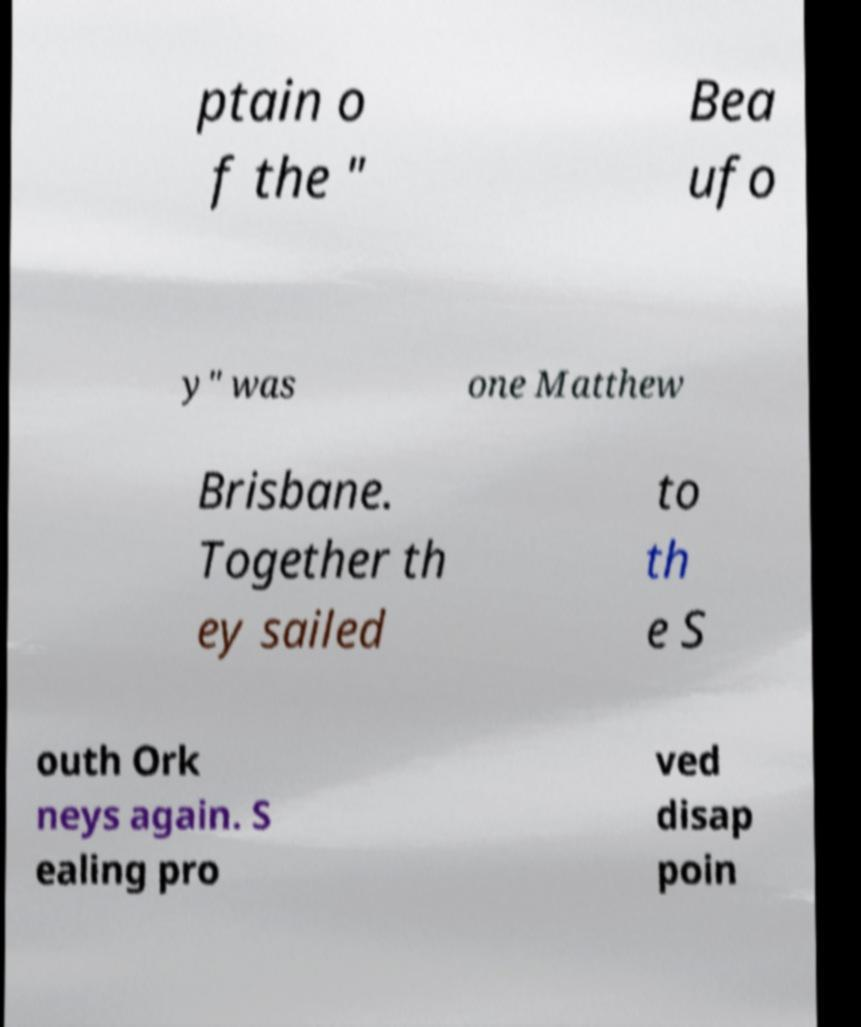Please identify and transcribe the text found in this image. ptain o f the " Bea ufo y" was one Matthew Brisbane. Together th ey sailed to th e S outh Ork neys again. S ealing pro ved disap poin 